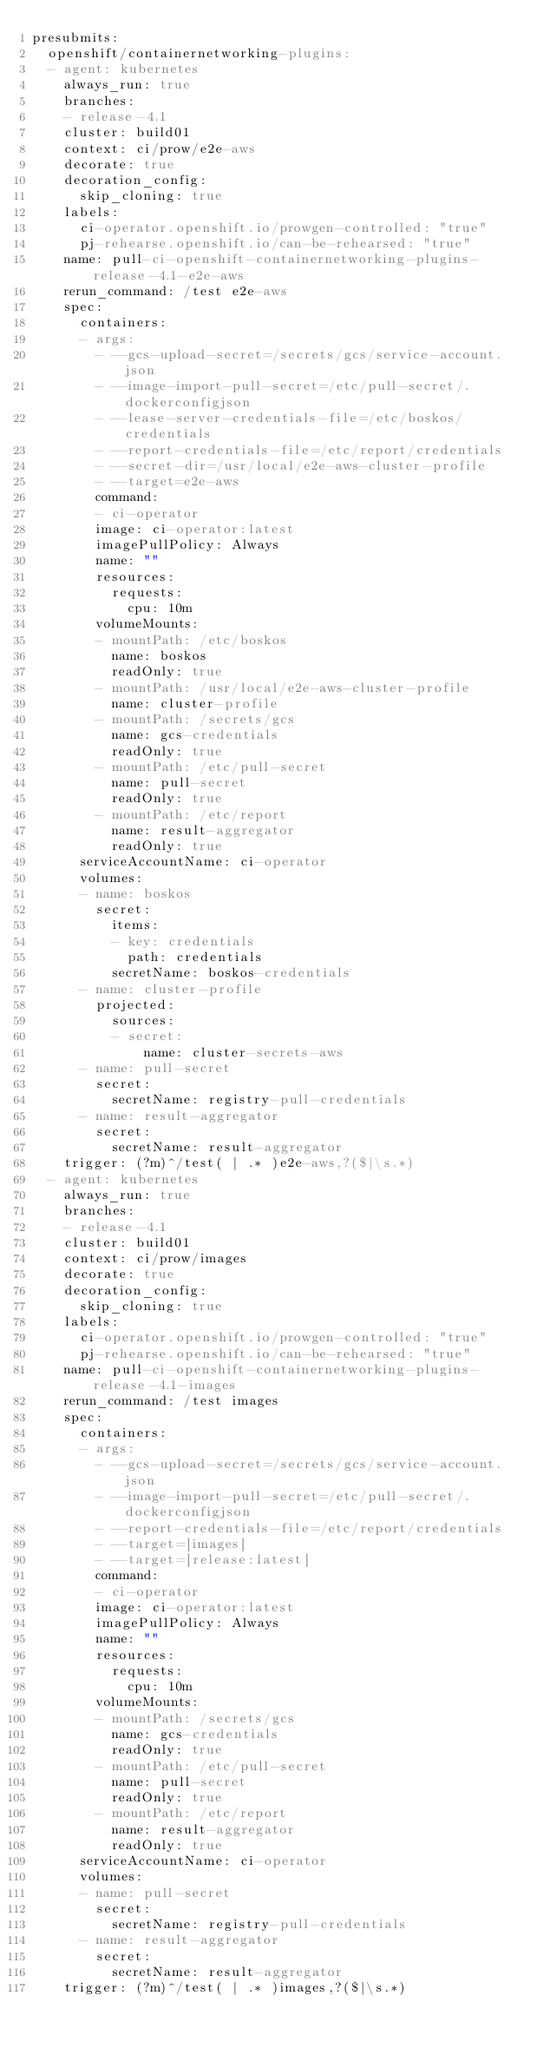Convert code to text. <code><loc_0><loc_0><loc_500><loc_500><_YAML_>presubmits:
  openshift/containernetworking-plugins:
  - agent: kubernetes
    always_run: true
    branches:
    - release-4.1
    cluster: build01
    context: ci/prow/e2e-aws
    decorate: true
    decoration_config:
      skip_cloning: true
    labels:
      ci-operator.openshift.io/prowgen-controlled: "true"
      pj-rehearse.openshift.io/can-be-rehearsed: "true"
    name: pull-ci-openshift-containernetworking-plugins-release-4.1-e2e-aws
    rerun_command: /test e2e-aws
    spec:
      containers:
      - args:
        - --gcs-upload-secret=/secrets/gcs/service-account.json
        - --image-import-pull-secret=/etc/pull-secret/.dockerconfigjson
        - --lease-server-credentials-file=/etc/boskos/credentials
        - --report-credentials-file=/etc/report/credentials
        - --secret-dir=/usr/local/e2e-aws-cluster-profile
        - --target=e2e-aws
        command:
        - ci-operator
        image: ci-operator:latest
        imagePullPolicy: Always
        name: ""
        resources:
          requests:
            cpu: 10m
        volumeMounts:
        - mountPath: /etc/boskos
          name: boskos
          readOnly: true
        - mountPath: /usr/local/e2e-aws-cluster-profile
          name: cluster-profile
        - mountPath: /secrets/gcs
          name: gcs-credentials
          readOnly: true
        - mountPath: /etc/pull-secret
          name: pull-secret
          readOnly: true
        - mountPath: /etc/report
          name: result-aggregator
          readOnly: true
      serviceAccountName: ci-operator
      volumes:
      - name: boskos
        secret:
          items:
          - key: credentials
            path: credentials
          secretName: boskos-credentials
      - name: cluster-profile
        projected:
          sources:
          - secret:
              name: cluster-secrets-aws
      - name: pull-secret
        secret:
          secretName: registry-pull-credentials
      - name: result-aggregator
        secret:
          secretName: result-aggregator
    trigger: (?m)^/test( | .* )e2e-aws,?($|\s.*)
  - agent: kubernetes
    always_run: true
    branches:
    - release-4.1
    cluster: build01
    context: ci/prow/images
    decorate: true
    decoration_config:
      skip_cloning: true
    labels:
      ci-operator.openshift.io/prowgen-controlled: "true"
      pj-rehearse.openshift.io/can-be-rehearsed: "true"
    name: pull-ci-openshift-containernetworking-plugins-release-4.1-images
    rerun_command: /test images
    spec:
      containers:
      - args:
        - --gcs-upload-secret=/secrets/gcs/service-account.json
        - --image-import-pull-secret=/etc/pull-secret/.dockerconfigjson
        - --report-credentials-file=/etc/report/credentials
        - --target=[images]
        - --target=[release:latest]
        command:
        - ci-operator
        image: ci-operator:latest
        imagePullPolicy: Always
        name: ""
        resources:
          requests:
            cpu: 10m
        volumeMounts:
        - mountPath: /secrets/gcs
          name: gcs-credentials
          readOnly: true
        - mountPath: /etc/pull-secret
          name: pull-secret
          readOnly: true
        - mountPath: /etc/report
          name: result-aggregator
          readOnly: true
      serviceAccountName: ci-operator
      volumes:
      - name: pull-secret
        secret:
          secretName: registry-pull-credentials
      - name: result-aggregator
        secret:
          secretName: result-aggregator
    trigger: (?m)^/test( | .* )images,?($|\s.*)
</code> 